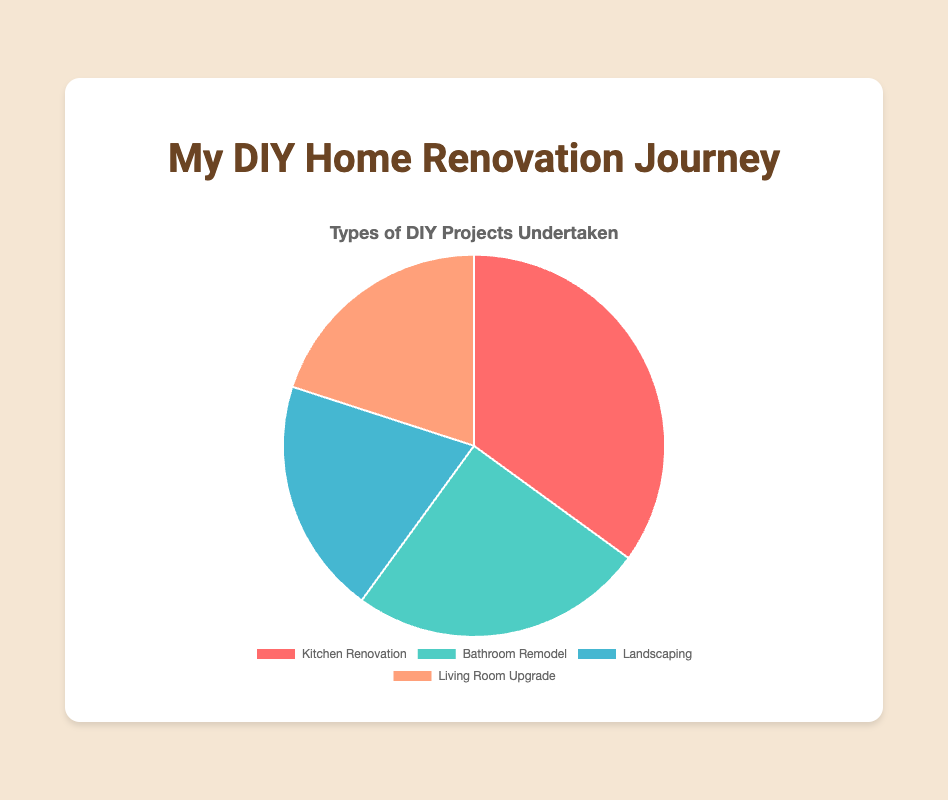- Which type of DIY project is undertaken the most? The Kitchen Renovation has the highest percentage in the pie chart at 35%, which indicates that it is the most undertaken project.
Answer: Kitchen Renovation - What's the total percentage of projects dedicated to indoor renovations? The indoor renovation projects are Kitchen Renovation, Bathroom Remodel, and Living Room Upgrade. Adding their percentages: 35% (Kitchen) + 25% (Bathroom) + 20% (Living Room) = 80%.
Answer: 80% - How does the percentage of Bathroom Remodel projects compare to Landscaping projects? The Bathroom Remodel has a percentage of 25%, and Landscaping has a percentage of 20%. Therefore, the Bathroom Remodel is undertaken more frequently than Landscaping by 5%.
Answer: Bathroom Remodel is 5% more - Are Kitchen Renovation projects more popular than Living Room Upgrades and Landscaping combined? Adding the percentages for Living Room Upgrade (20%) and Landscaping (20%) gives 40%, which is greater than Kitchen Renovation at 35%. So, Kitchen Renovation is not more popular.
Answer: No - What is the least undertaken type of DIY project according to the chart? Both Landscaping and Living Room Upgrade have the lowest percentages at 20%, making them the least undertaken projects.
Answer: Landscaping and Living Room Upgrade - What fraction of all projects are Bathroom Remodel projects? The Bathroom Remodel projects account for 25% of the total projects. Converting the percentage to a fraction: 25/100 = 1/4.
Answer: 1/4 - If you were to group all outdoor projects, what fraction of the total do they represent? The only outdoor project is Landscaping, which represents 20% of the total. Therefore, the fraction is 20/100 = 1/5.
Answer: 1/5 - Which segment of the pie chart is represented by a blue color? According to the color code in the description, the blue color represents the Landscaping projects.
Answer: Landscaping - By how much does the percentage of Kitchen Renovation exceed that of Bathroom Remodel? The Kitchen Renovation percentage is 35%, and Bathroom Remodel is 25%. So, Kitchen Renovation exceeds Bathroom Remodel by 35% - 25% = 10%.
Answer: 10% - If the total number of projects documented was 100, how many projects for each type would there be? To find the number of projects, multiply the percentages by 100. For Kitchen Renovation: 35%, so 35 projects; Bathroom Remodel: 25%, so 25 projects; Landscaping: 20%, so 20 projects; Living Room Upgrade: 20%, so 20 projects.
Answer: 35 Kitchen Renovation, 25 Bathroom Remodel, 20 Landscaping, 20 Living Room Upgrade 